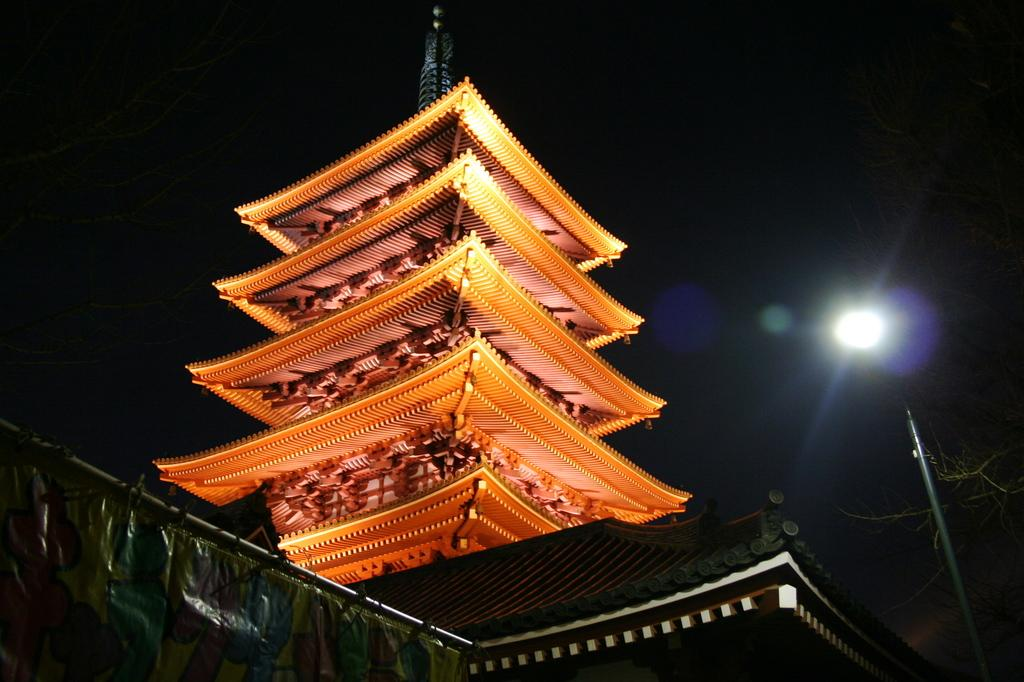What is the main subject of the image? The main subject of the image is a building top. When was the image taken? The image was taken during nighttime. Can you describe any specific features in the image? There is a light focus visible on the right side of the image. How would you describe the overall lighting in the image? The background of the image is very dark. How many mice can be seen sleeping in the image? There are no mice present in the image, and therefore no sleeping mice can be observed. 